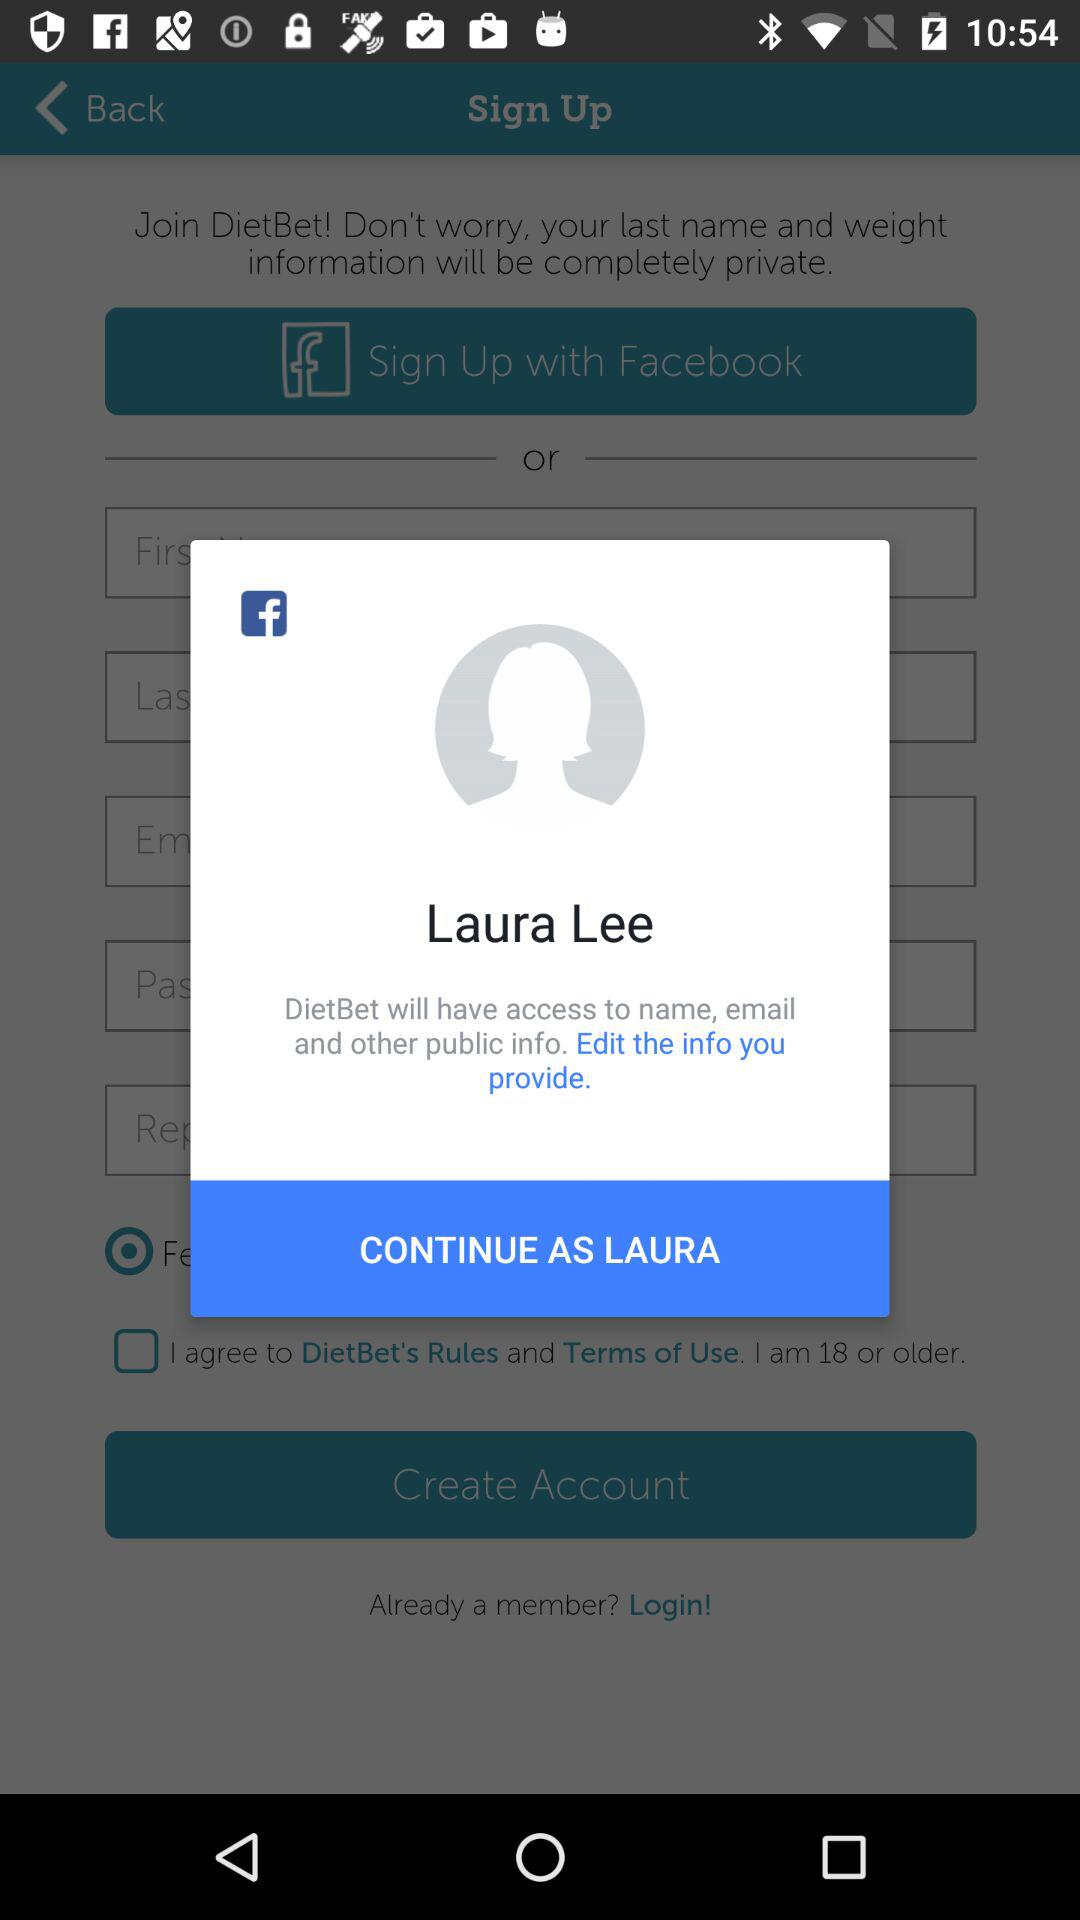What is the user's name? The user's name is Laura Lee. 